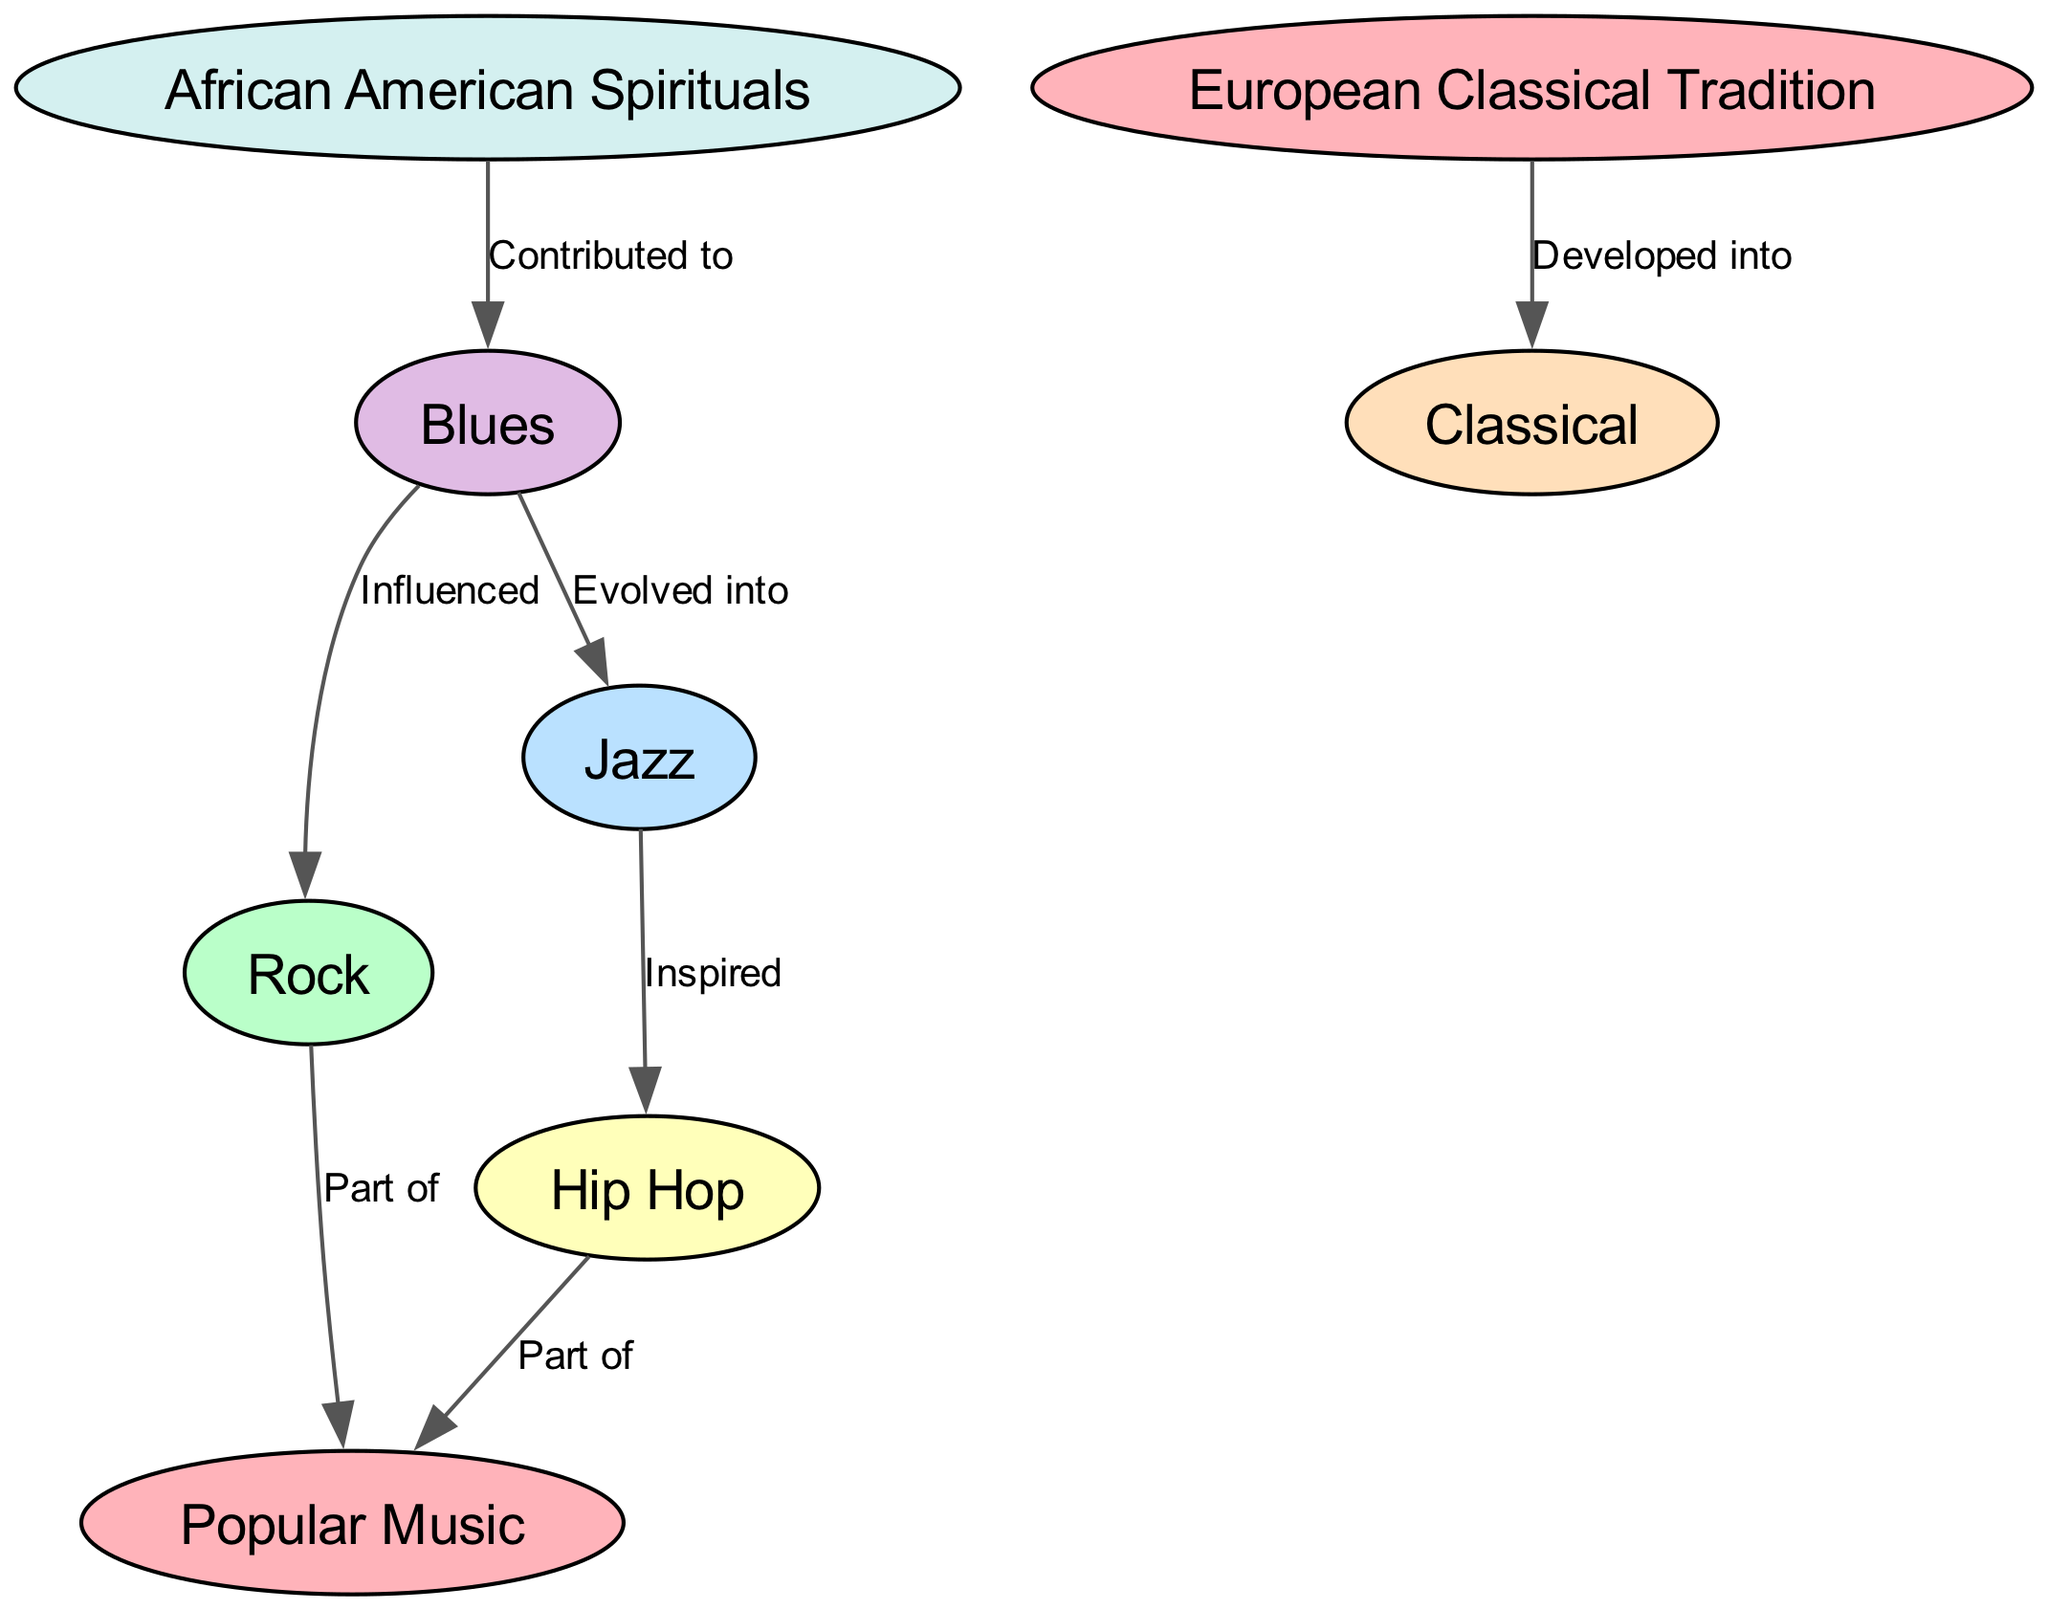What is the total number of nodes in the diagram? The diagram consists of various genres of music, and we can count each node listed under "nodes." There are 8 nodes in total: Popular Music, Rock, Jazz, Hip Hop, Classical, Blues, African American Spirituals, and European Classical Tradition.
Answer: 8 Which genre evolved from Blues? Looking at the edges, the direction from Blues leads directly to Jazz, indicating that Jazz evolved from Blues.
Answer: Jazz What influences Rock music according to the diagram? The diagram shows an edge from Blues to Rock labeled "Influenced," meaning Blues has an influence on Rock music.
Answer: Blues How many genres are classified as part of Popular Music? There are two edges leading from genres to Popular Music: one from Rock and one from Hip Hop, indicating that these two genres are part of Popular Music.
Answer: 2 Which genre is influenced by Jazz? The information in the diagram indicates that Hip Hop is inspired by Jazz, with a directed edge showing this relationship.
Answer: Hip Hop What genre developed from the European Classical Tradition? The diagram denotes an edge labeled "Developed into" that connects European Classical Tradition to Classical music, showing the evolutionary relationship.
Answer: Classical Which two genres share a direct contribution relationship? Analyzing the edges, we find that African American Spirituals contributed to Blues. Therefore, these two genres share a direct relationship of contribution.
Answer: African American Spirituals and Blues Which genre is not influenced by African American Spirituals? By reviewing the edges, we note that while Blues is influenced by African American Spirituals, genres like Rock, Hip Hop, and Classical do not show influence from African American Spirituals. Thus, they are not influenced by it.
Answer: Rock, Hip Hop, Classical 